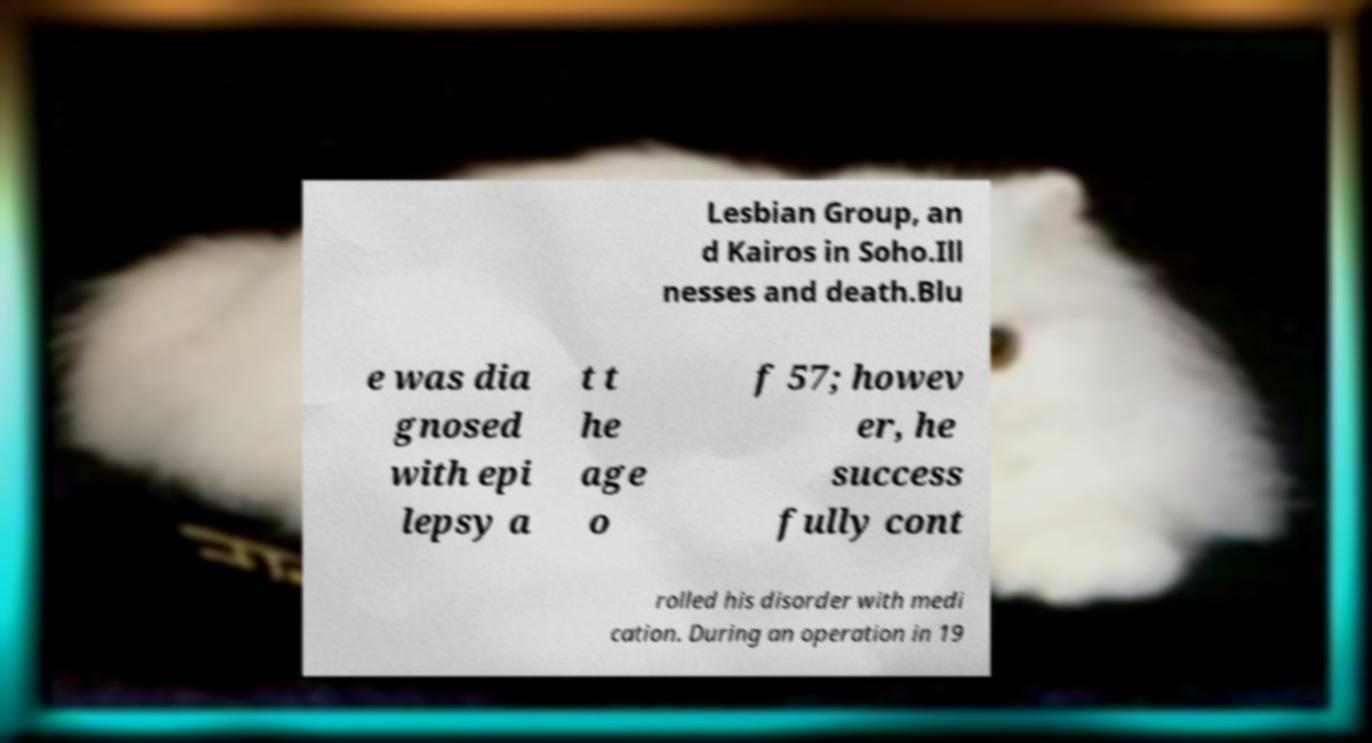Could you assist in decoding the text presented in this image and type it out clearly? Lesbian Group, an d Kairos in Soho.Ill nesses and death.Blu e was dia gnosed with epi lepsy a t t he age o f 57; howev er, he success fully cont rolled his disorder with medi cation. During an operation in 19 